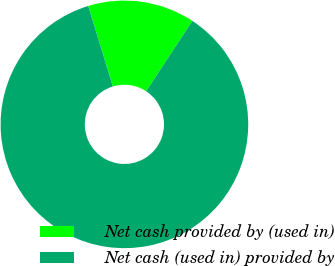Convert chart. <chart><loc_0><loc_0><loc_500><loc_500><pie_chart><fcel>Net cash provided by (used in)<fcel>Net cash (used in) provided by<nl><fcel>13.97%<fcel>86.03%<nl></chart> 